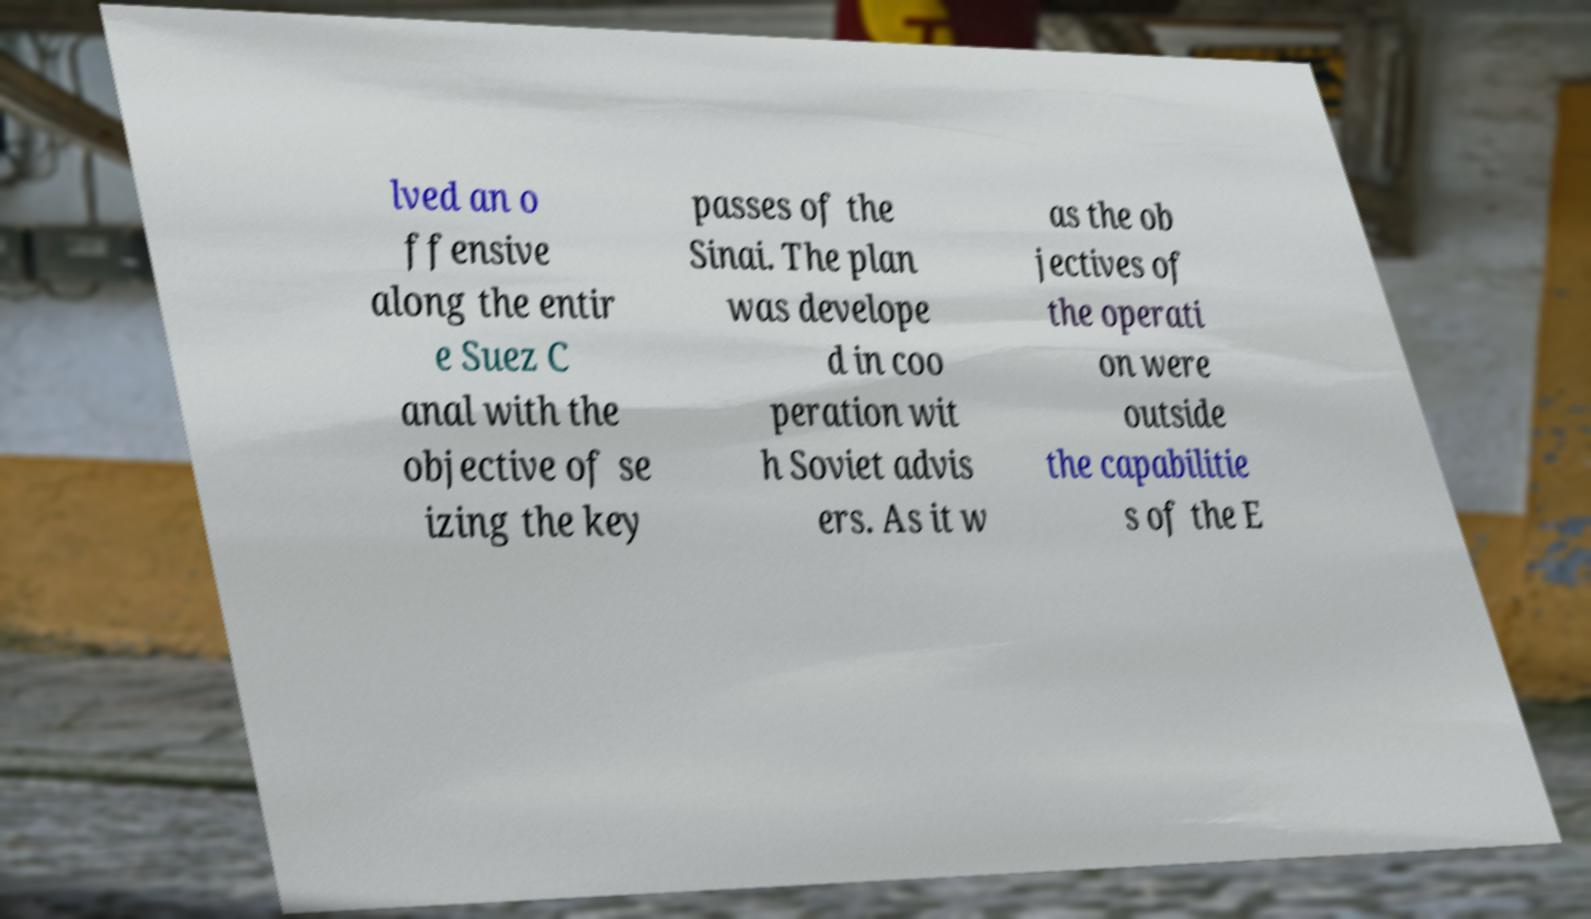What messages or text are displayed in this image? I need them in a readable, typed format. lved an o ffensive along the entir e Suez C anal with the objective of se izing the key passes of the Sinai. The plan was develope d in coo peration wit h Soviet advis ers. As it w as the ob jectives of the operati on were outside the capabilitie s of the E 